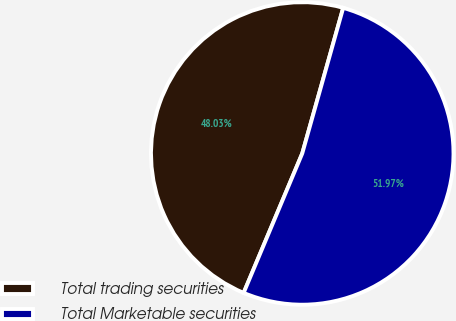<chart> <loc_0><loc_0><loc_500><loc_500><pie_chart><fcel>Total trading securities<fcel>Total Marketable securities<nl><fcel>48.03%<fcel>51.97%<nl></chart> 